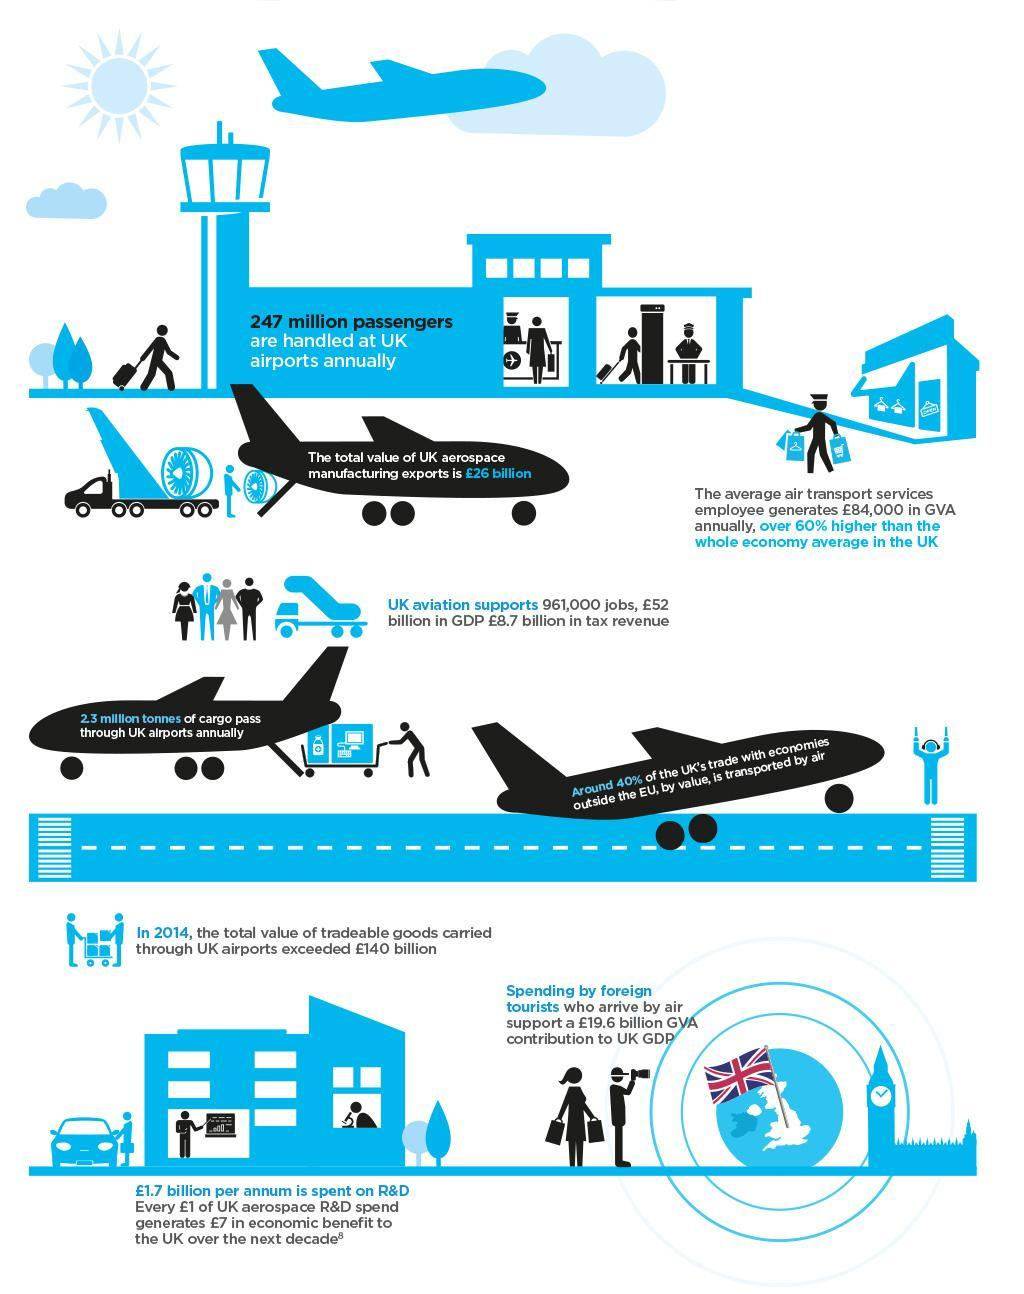How does near to 20 billion pounds contribution to GDP come?
Answer the question with a short phrase. Spending by foreign tourists How many are employed by the UK's aviation industry? 961,000 